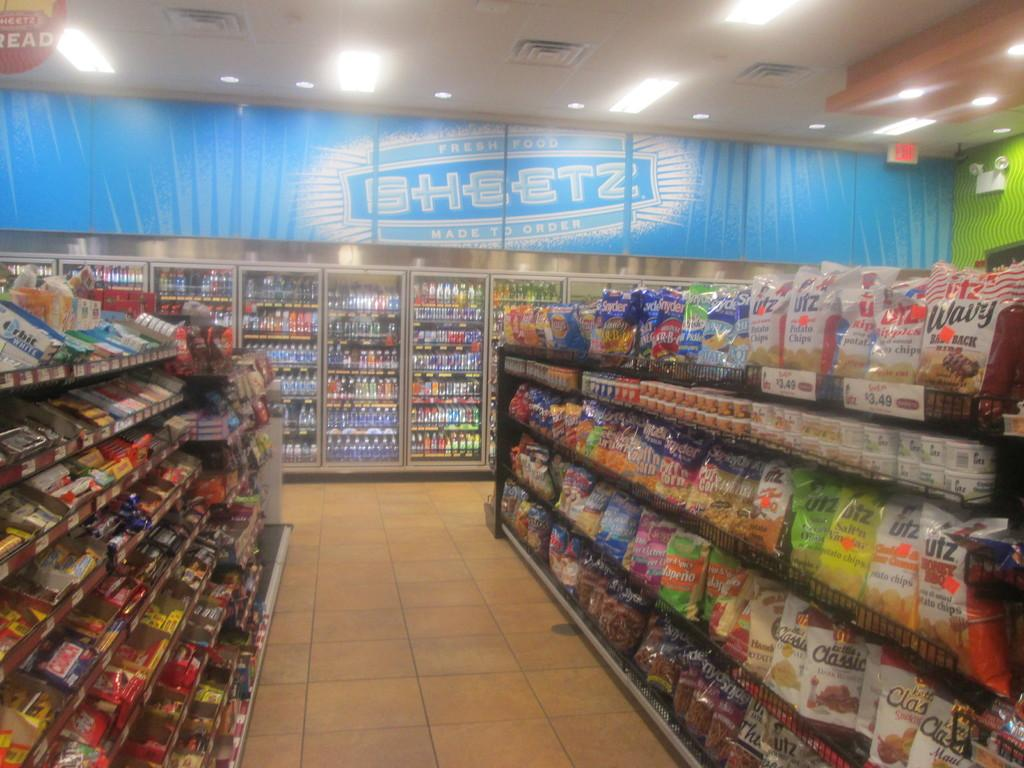<image>
Summarize the visual content of the image. A sign that says SHEETZ is above the drink cases in this store. 